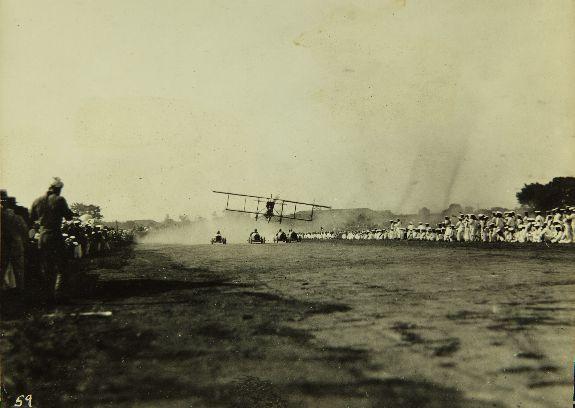What type of plane is this?
Give a very brief answer. Biplane. What is sailing on water?
Write a very short answer. Nothing. Is there a typhoon brewing in the distance?
Answer briefly. No. What is under the plane?
Short answer required. Cars. In what season was this picture taken?
Answer briefly. Fall. 